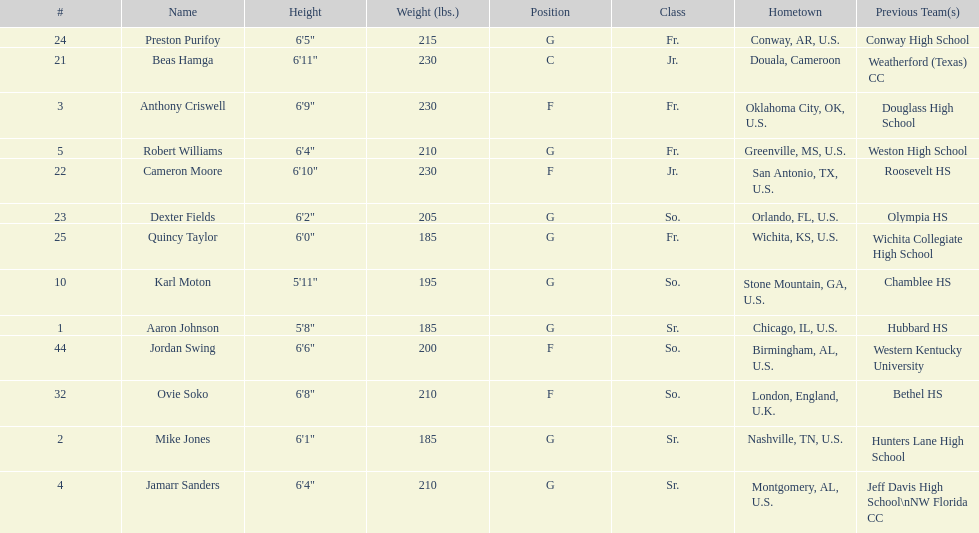Who is first on the roster? Aaron Johnson. 